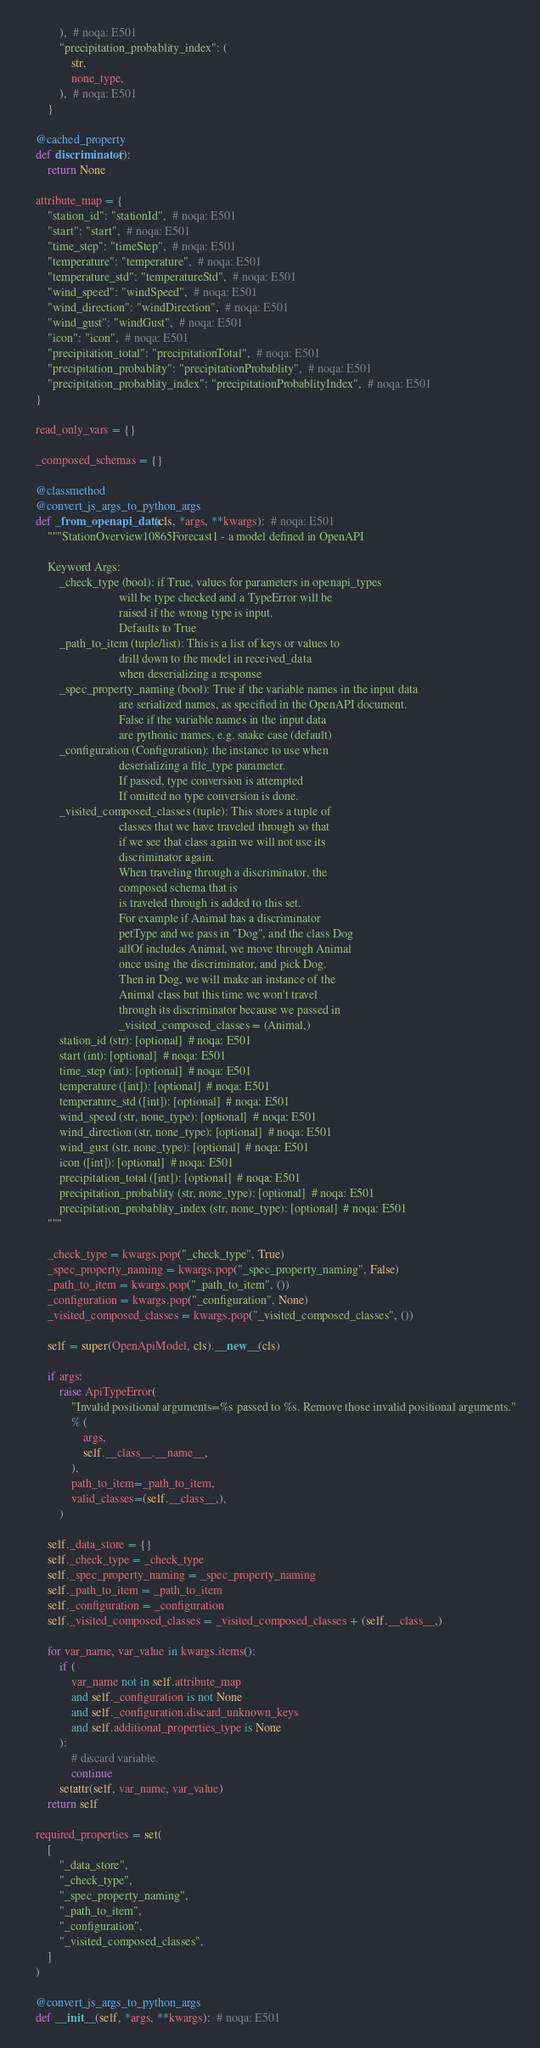Convert code to text. <code><loc_0><loc_0><loc_500><loc_500><_Python_>            ),  # noqa: E501
            "precipitation_probablity_index": (
                str,
                none_type,
            ),  # noqa: E501
        }

    @cached_property
    def discriminator():
        return None

    attribute_map = {
        "station_id": "stationId",  # noqa: E501
        "start": "start",  # noqa: E501
        "time_step": "timeStep",  # noqa: E501
        "temperature": "temperature",  # noqa: E501
        "temperature_std": "temperatureStd",  # noqa: E501
        "wind_speed": "windSpeed",  # noqa: E501
        "wind_direction": "windDirection",  # noqa: E501
        "wind_gust": "windGust",  # noqa: E501
        "icon": "icon",  # noqa: E501
        "precipitation_total": "precipitationTotal",  # noqa: E501
        "precipitation_probablity": "precipitationProbablity",  # noqa: E501
        "precipitation_probablity_index": "precipitationProbablityIndex",  # noqa: E501
    }

    read_only_vars = {}

    _composed_schemas = {}

    @classmethod
    @convert_js_args_to_python_args
    def _from_openapi_data(cls, *args, **kwargs):  # noqa: E501
        """StationOverview10865Forecast1 - a model defined in OpenAPI

        Keyword Args:
            _check_type (bool): if True, values for parameters in openapi_types
                                will be type checked and a TypeError will be
                                raised if the wrong type is input.
                                Defaults to True
            _path_to_item (tuple/list): This is a list of keys or values to
                                drill down to the model in received_data
                                when deserializing a response
            _spec_property_naming (bool): True if the variable names in the input data
                                are serialized names, as specified in the OpenAPI document.
                                False if the variable names in the input data
                                are pythonic names, e.g. snake case (default)
            _configuration (Configuration): the instance to use when
                                deserializing a file_type parameter.
                                If passed, type conversion is attempted
                                If omitted no type conversion is done.
            _visited_composed_classes (tuple): This stores a tuple of
                                classes that we have traveled through so that
                                if we see that class again we will not use its
                                discriminator again.
                                When traveling through a discriminator, the
                                composed schema that is
                                is traveled through is added to this set.
                                For example if Animal has a discriminator
                                petType and we pass in "Dog", and the class Dog
                                allOf includes Animal, we move through Animal
                                once using the discriminator, and pick Dog.
                                Then in Dog, we will make an instance of the
                                Animal class but this time we won't travel
                                through its discriminator because we passed in
                                _visited_composed_classes = (Animal,)
            station_id (str): [optional]  # noqa: E501
            start (int): [optional]  # noqa: E501
            time_step (int): [optional]  # noqa: E501
            temperature ([int]): [optional]  # noqa: E501
            temperature_std ([int]): [optional]  # noqa: E501
            wind_speed (str, none_type): [optional]  # noqa: E501
            wind_direction (str, none_type): [optional]  # noqa: E501
            wind_gust (str, none_type): [optional]  # noqa: E501
            icon ([int]): [optional]  # noqa: E501
            precipitation_total ([int]): [optional]  # noqa: E501
            precipitation_probablity (str, none_type): [optional]  # noqa: E501
            precipitation_probablity_index (str, none_type): [optional]  # noqa: E501
        """

        _check_type = kwargs.pop("_check_type", True)
        _spec_property_naming = kwargs.pop("_spec_property_naming", False)
        _path_to_item = kwargs.pop("_path_to_item", ())
        _configuration = kwargs.pop("_configuration", None)
        _visited_composed_classes = kwargs.pop("_visited_composed_classes", ())

        self = super(OpenApiModel, cls).__new__(cls)

        if args:
            raise ApiTypeError(
                "Invalid positional arguments=%s passed to %s. Remove those invalid positional arguments."
                % (
                    args,
                    self.__class__.__name__,
                ),
                path_to_item=_path_to_item,
                valid_classes=(self.__class__,),
            )

        self._data_store = {}
        self._check_type = _check_type
        self._spec_property_naming = _spec_property_naming
        self._path_to_item = _path_to_item
        self._configuration = _configuration
        self._visited_composed_classes = _visited_composed_classes + (self.__class__,)

        for var_name, var_value in kwargs.items():
            if (
                var_name not in self.attribute_map
                and self._configuration is not None
                and self._configuration.discard_unknown_keys
                and self.additional_properties_type is None
            ):
                # discard variable.
                continue
            setattr(self, var_name, var_value)
        return self

    required_properties = set(
        [
            "_data_store",
            "_check_type",
            "_spec_property_naming",
            "_path_to_item",
            "_configuration",
            "_visited_composed_classes",
        ]
    )

    @convert_js_args_to_python_args
    def __init__(self, *args, **kwargs):  # noqa: E501</code> 